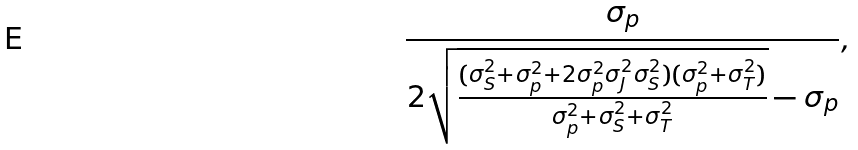Convert formula to latex. <formula><loc_0><loc_0><loc_500><loc_500>\frac { \sigma _ { p } } { 2 \sqrt { \frac { ( \sigma ^ { 2 } _ { S } + \sigma ^ { 2 } _ { p } + 2 \sigma ^ { 2 } _ { p } \sigma ^ { 2 } _ { J } \sigma ^ { 2 } _ { S } ) ( \sigma ^ { 2 } _ { p } + \sigma ^ { 2 } _ { T } ) } { \sigma ^ { 2 } _ { p } + \sigma ^ { 2 } _ { S } + \sigma ^ { 2 } _ { T } } } - \sigma _ { p } } ,</formula> 